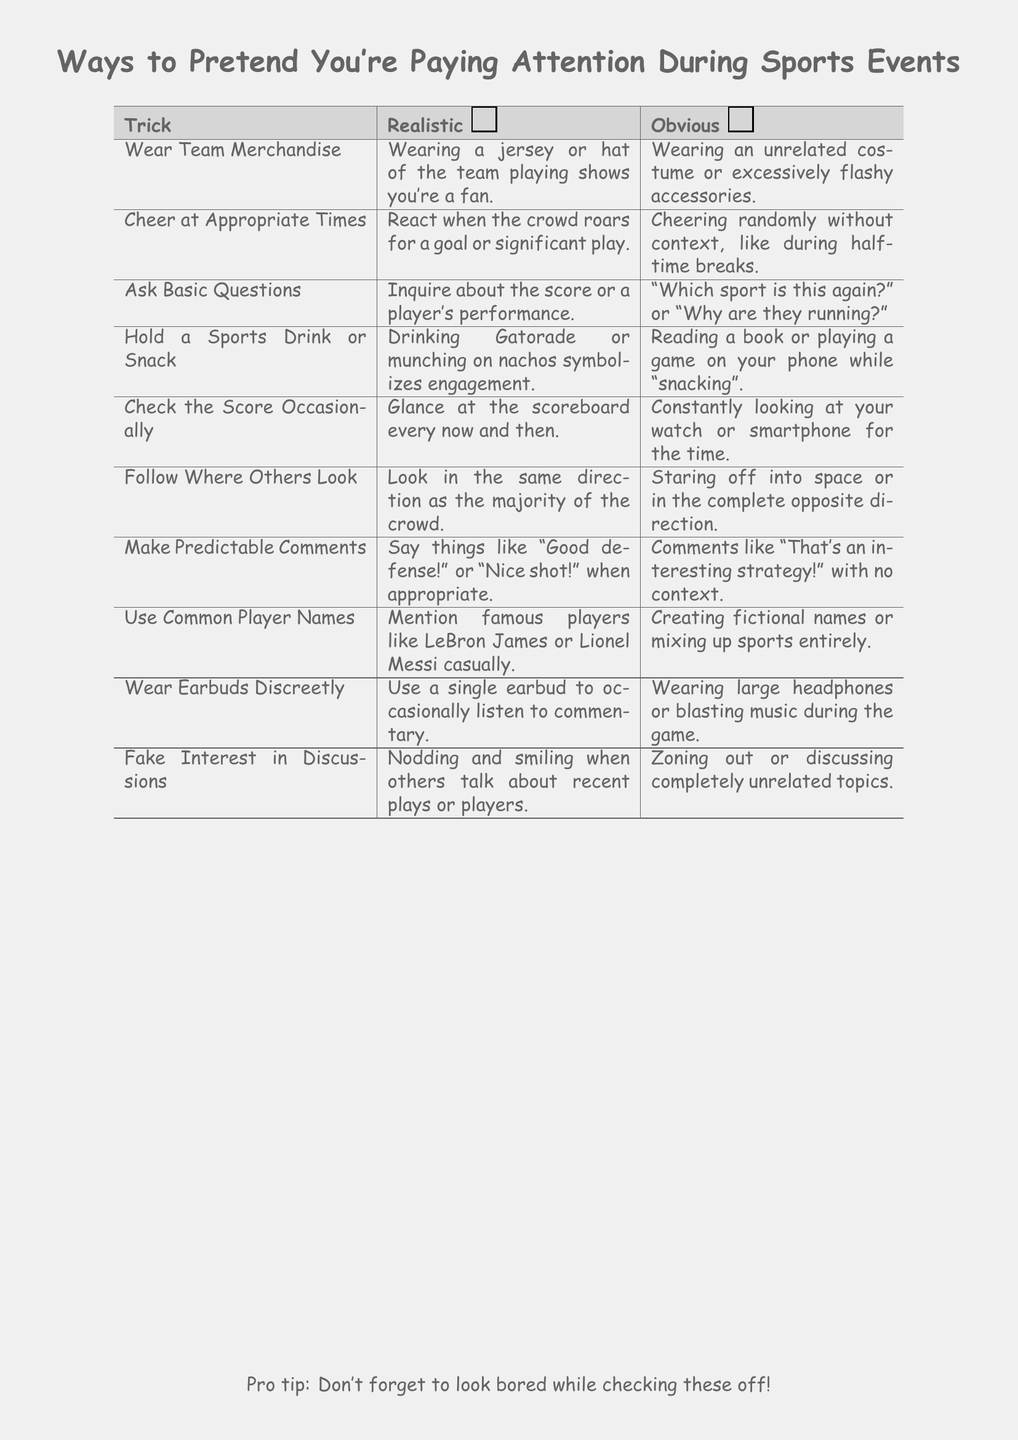What is the title of the document? The title is prominently displayed at the top of the document.
Answer: Ways to Pretend You're Paying Attention During Sports Events How many tricks are listed in the table? The table has a total of 10 tricks listed in it.
Answer: 10 What is one realistic trick to pretend you are paying attention? One of the tricks involves actively participating during the game, as described in the table.
Answer: Cheer at Appropriate Times What common player name is mentioned in the document? The document includes references to well-known athletes as examples of common player names.
Answer: LeBron James What should you wear to appear as a fan? Wearing something to identify with the team is suggested as a trick in the document.
Answer: Team Merchandise What type of questions should you ask to seem engaged? The document suggests asking questions related to the event without showing ignorance.
Answer: Basic Questions What comment is considered predictable according to the checklist? A comment indicating approval of a player's performance fits the criteria of being predictable.
Answer: Good defense! How can you discreetly listen to commentary? The document suggests using a subtle method to stay informed without drawing attention.
Answer: Wear Earbuds Discreetly What is a sign of disinterest according to the document? The content provides examples of actions that would indicate a lack of engagement.
Answer: Zoning out What kind of snacks should you hold? The document implies that holding a certain type of snack can enhance the appearance of interest.
Answer: Sports Drink or Snack 